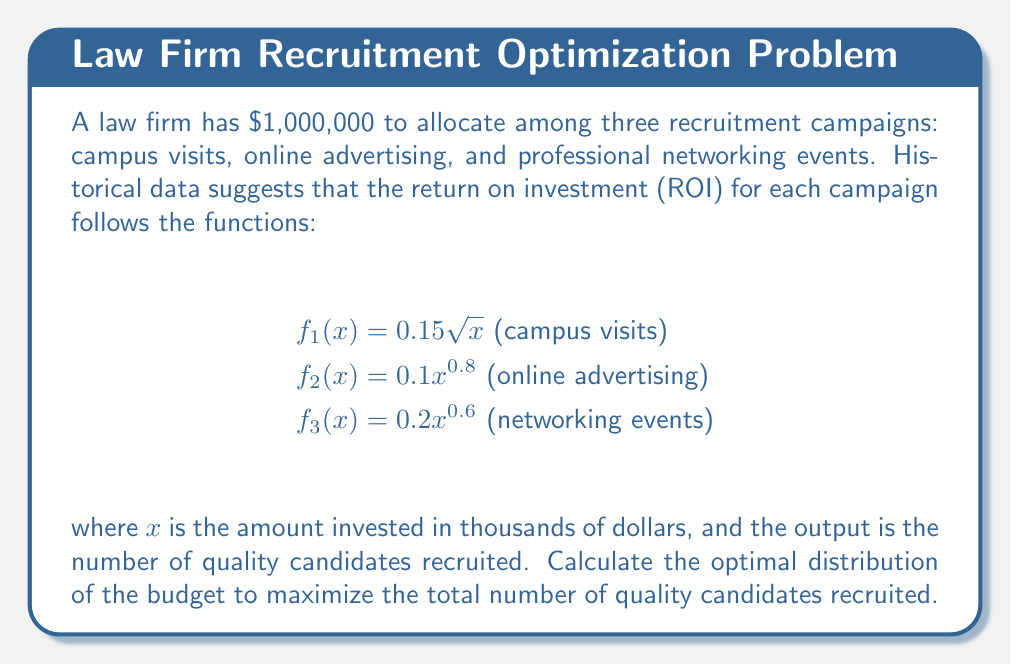Can you solve this math problem? To solve this problem, we'll use the method of Lagrange multipliers:

1) Let $x$, $y$, and $z$ represent the amounts (in thousands) allocated to campus visits, online advertising, and networking events respectively.

2) Our objective function is:
   $$F(x,y,z) = 0.15\sqrt{x} + 0.1y^{0.8} + 0.2z^{0.6}$$

3) Our constraint is:
   $$g(x,y,z) = x + y + z - 1000 = 0$$

4) We form the Lagrangian:
   $$L(x,y,z,\lambda) = 0.15\sqrt{x} + 0.1y^{0.8} + 0.2z^{0.6} - \lambda(x + y + z - 1000)$$

5) We set partial derivatives equal to zero:

   $$\frac{\partial L}{\partial x} = \frac{0.075}{\sqrt{x}} - \lambda = 0$$
   $$\frac{\partial L}{\partial y} = 0.08y^{-0.2} - \lambda = 0$$
   $$\frac{\partial L}{\partial z} = 0.12z^{-0.4} - \lambda = 0$$
   $$\frac{\partial L}{\partial \lambda} = x + y + z - 1000 = 0$$

6) From these equations, we can derive:

   $$x = \left(\frac{0.075}{\lambda}\right)^2$$
   $$y = \left(\frac{0.08}{\lambda}\right)^{5/4}$$
   $$z = \left(\frac{0.12}{\lambda}\right)^{5/3}$$

7) Substituting these into the constraint equation:

   $$\left(\frac{0.075}{\lambda}\right)^2 + \left(\frac{0.08}{\lambda}\right)^{5/4} + \left(\frac{0.12}{\lambda}\right)^{5/3} = 1000$$

8) Solving this numerically (as it's not easily solvable analytically), we get:
   $$\lambda \approx 0.002415$$

9) Substituting this value back into our equations for $x$, $y$, and $z$:

   $$x \approx 964.22$$
   $$y \approx 24.76$$
   $$z \approx 11.02$$

10) Rounding to the nearest thousand dollars:
    Campus visits: $964,000
    Online advertising: $25,000
    Networking events: $11,000
Answer: Campus visits: $964,000; Online advertising: $25,000; Networking events: $11,000 